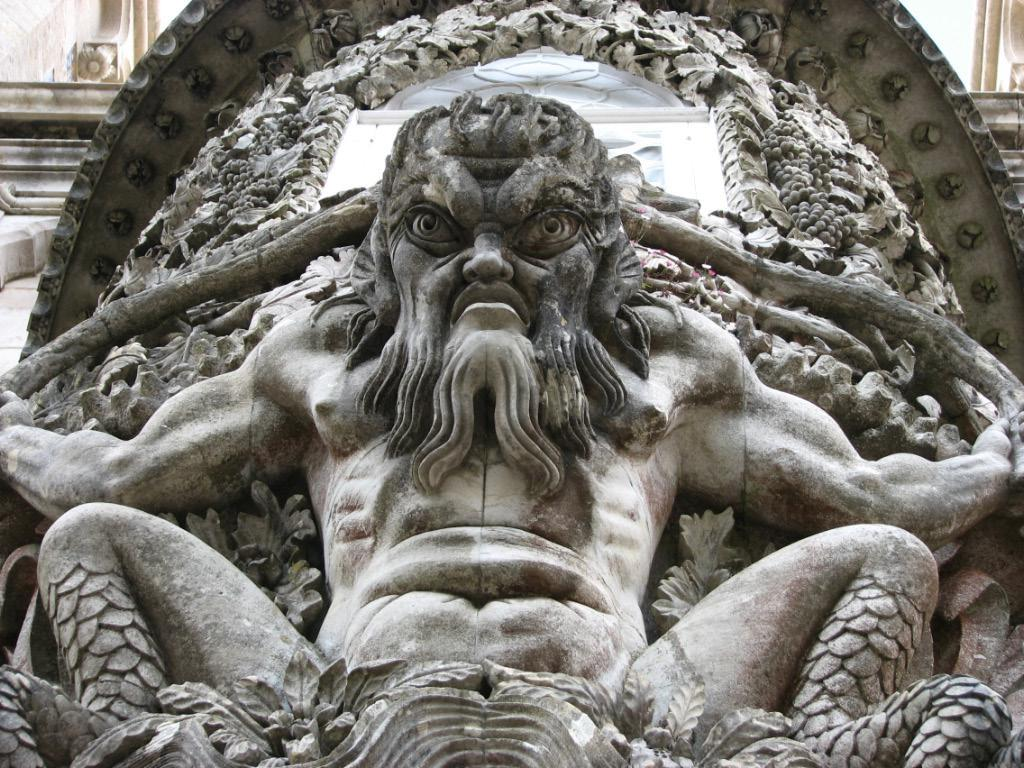What is the main subject of the image? There is a sculpture in the center of the image. Can you describe the sculpture in more detail? Unfortunately, the provided facts do not include any additional details about the sculpture. Is there anything else visible in the image besides the sculpture? The provided facts do not mention any other objects or subjects in the image. What type of alley can be seen behind the sculpture in the image? There is no alley visible in the image; the provided facts only mention the presence of a sculpture. How does the robin support the sculpture in the image? There is no robin present in the image, so it cannot be providing any support to the sculpture. 